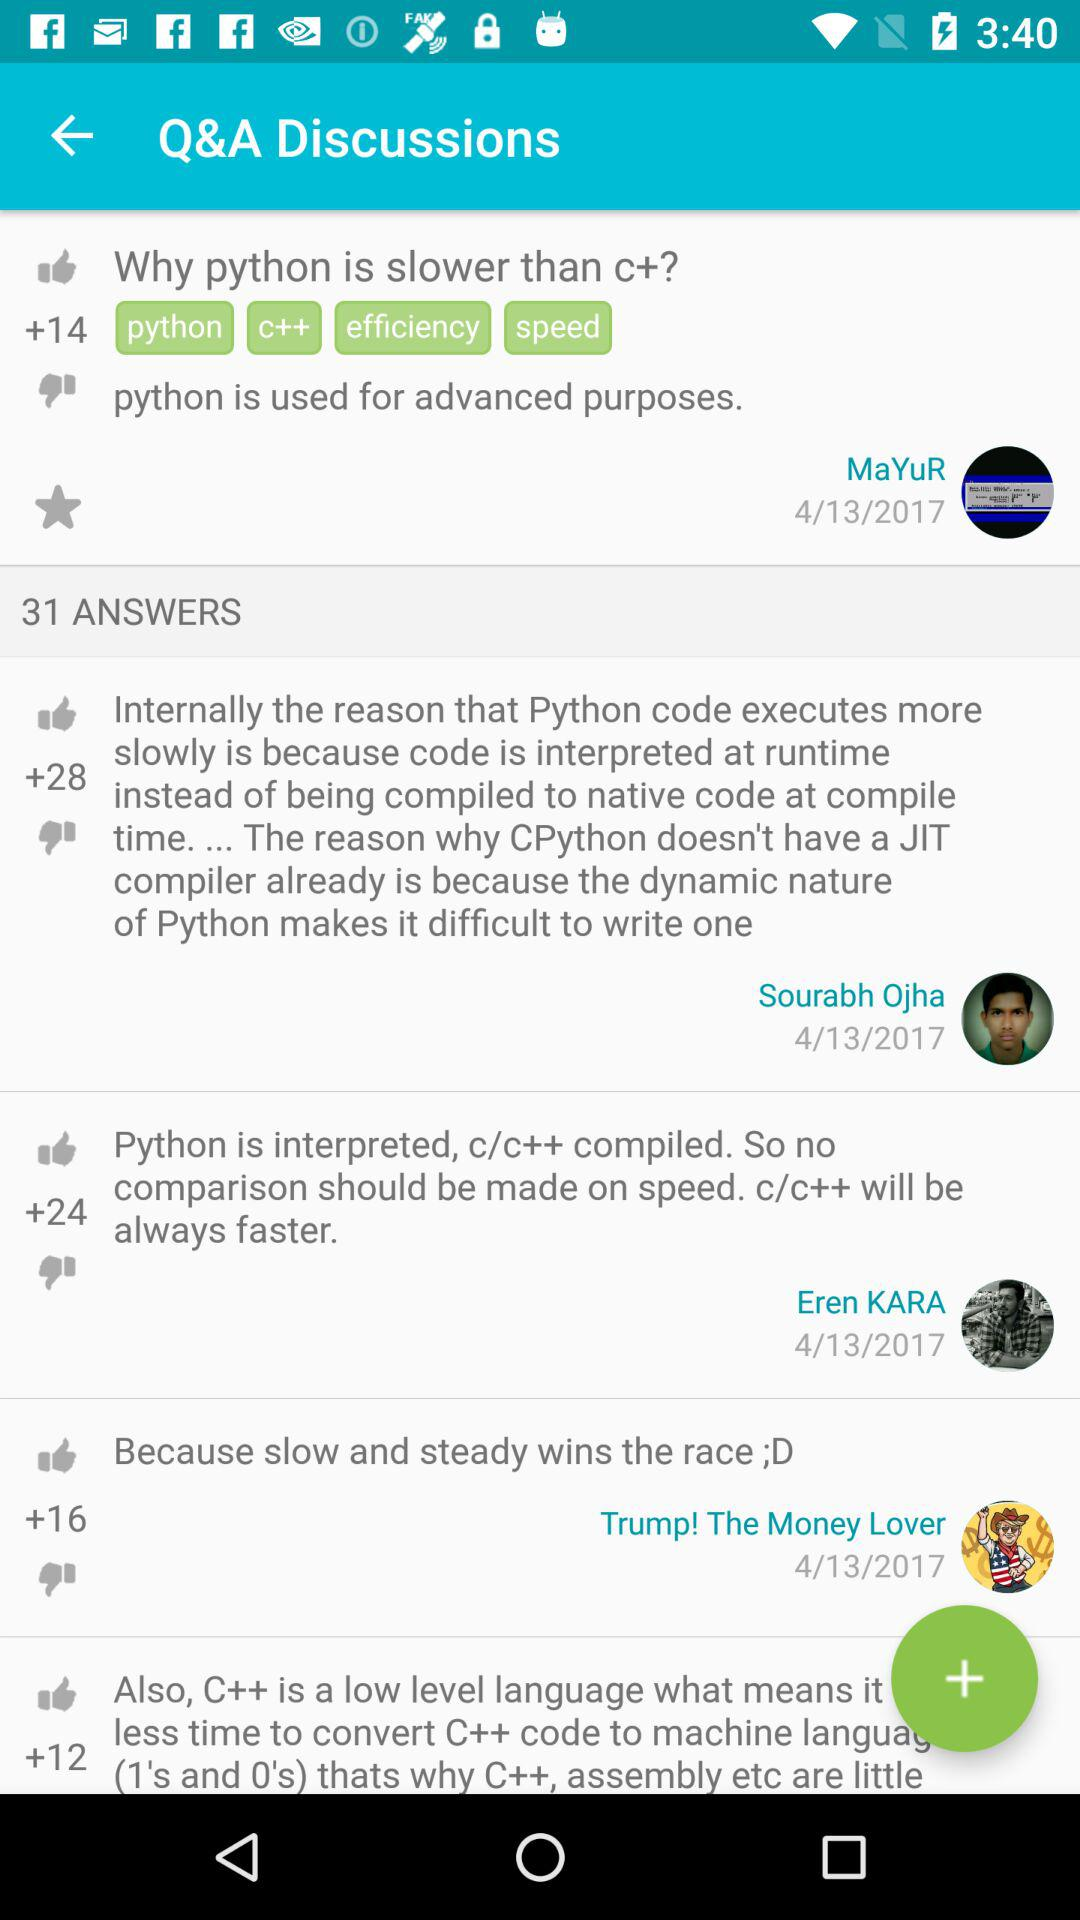How many answers are there? There are 31 answers. 